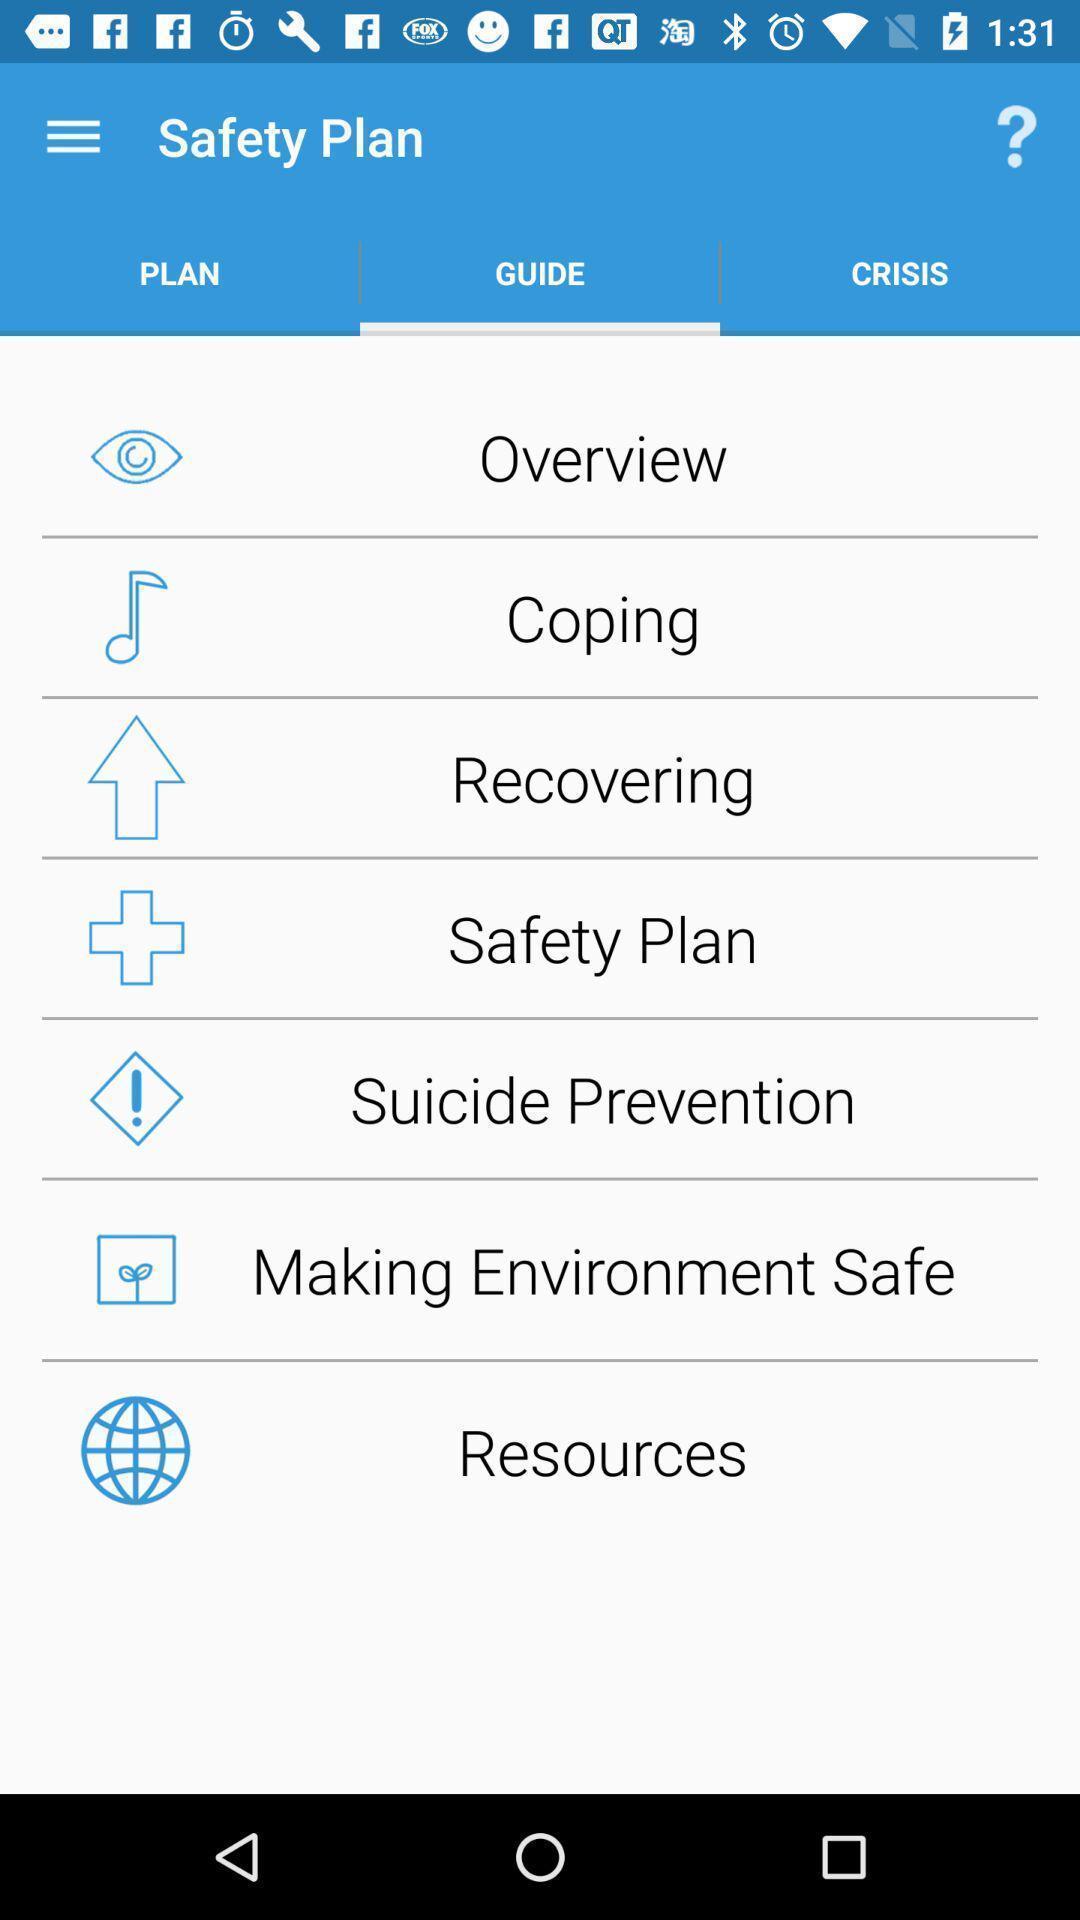Describe the key features of this screenshot. Screen shows a guide for safety plan. 